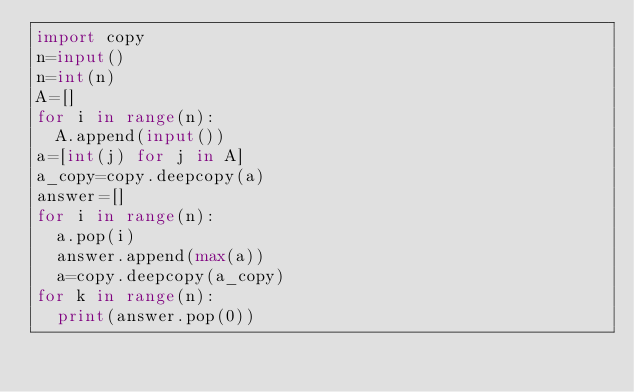Convert code to text. <code><loc_0><loc_0><loc_500><loc_500><_Python_>import copy
n=input()
n=int(n)
A=[]
for i in range(n):
  A.append(input())
a=[int(j) for j in A]
a_copy=copy.deepcopy(a)
answer=[]
for i in range(n):
  a.pop(i)
  answer.append(max(a))
  a=copy.deepcopy(a_copy)
for k in range(n):
  print(answer.pop(0))</code> 